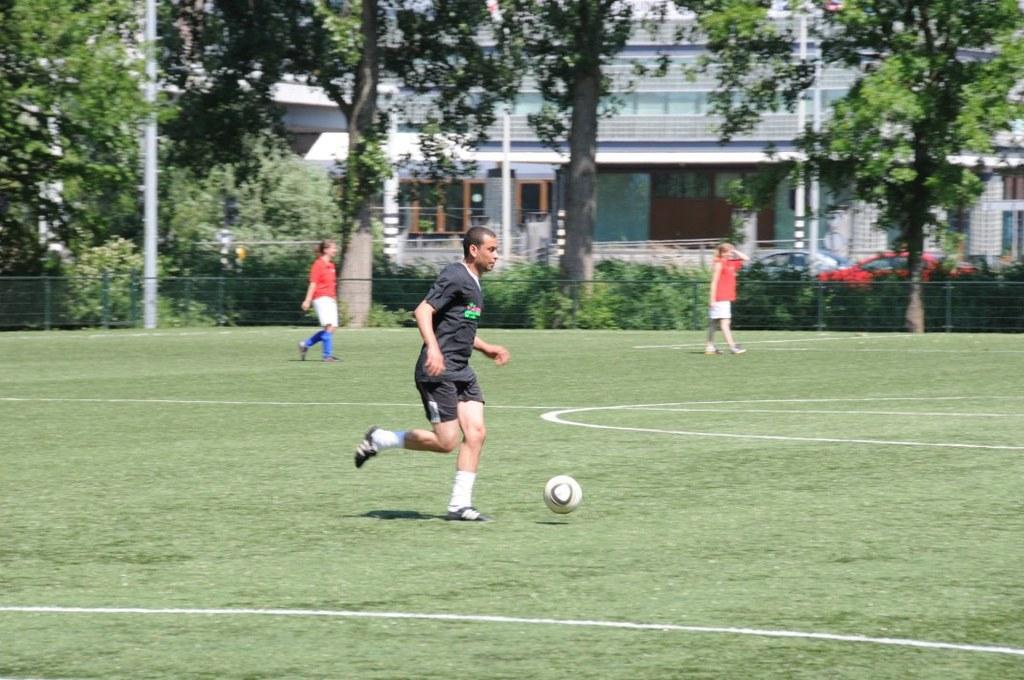Please provide a concise description of this image. In this image there are persons playing. In the background there are trees, there is building and there's grass on the ground. 